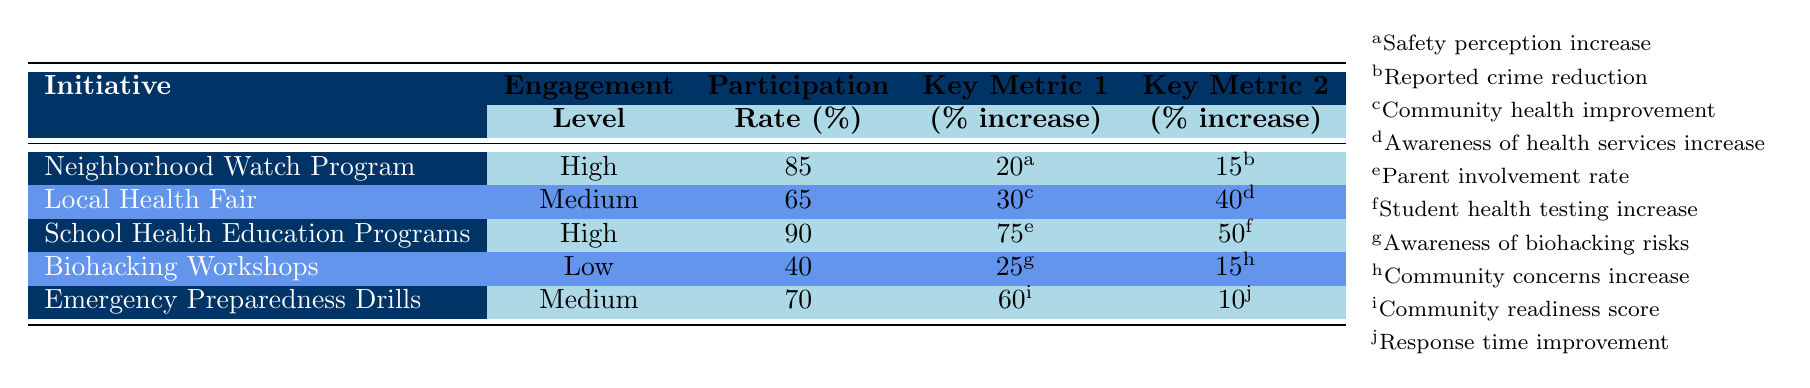What is the participation rate of the Neighborhood Watch Program? The Neighborhood Watch Program has a participation rate listed in the table. By locating the row for the Neighborhood Watch Program, we see the participation rate is 85%.
Answer: 85% Which initiative has the highest engagement level? The engagement levels for each initiative are given in the table. By comparing these levels, we find that both the Neighborhood Watch Program and the School Health Education Programs are marked as "High."
Answer: Neighborhood Watch Program and School Health Education Programs What is the reported crime reduction associated with the Neighborhood Watch Program? The table indicates a reported crime reduction value. By checking the Neighborhood Watch Program row, we find the value is 15%.
Answer: 15% Is the engagement level of Biohacking Workshops considered high? According to the table, the engagement level for Biohacking Workshops is marked as "Low." Thus, it cannot be considered high.
Answer: No What is the average participation rate of the initiatives with medium engagement levels? First, we identify the initiatives classified as "Medium," which are the Local Health Fair and Emergency Preparedness Drills. Their participation rates are 65% and 70%, respectively. We calculate the average by adding these two rates (65 + 70 = 135) and then dividing by the number of initiatives (135 / 2 = 67.5). Therefore, the average participation rate for the medium engagement initiatives is 67.5%.
Answer: 67.5% How much has awareness of health services increased in the Local Health Fair compared to awareness of biohacking risks in the Biohacking Workshops? We need to look at the increase values for awareness for both initiatives. The Local Health Fair shows an awareness increase of 40%, and the Biohacking Workshops show 25%. We find the difference by subtracting the two: 40 - 25 = 15%. Thus, awareness of health services has increased 15% more than awareness of biohacking risks.
Answer: 15% What is the parent involvement rate for the School Health Education Programs? The table includes a specific metric for parent involvement in the School Health Education Programs. Referencing this row, we see the parent involvement rate is 75%.
Answer: 75% Which initiative has the lowest participation rate? We can check the participation rates of all initiatives in the table, where the Biohacking Workshops has the lowest rate listed at 40%.
Answer: Biohacking Workshops 